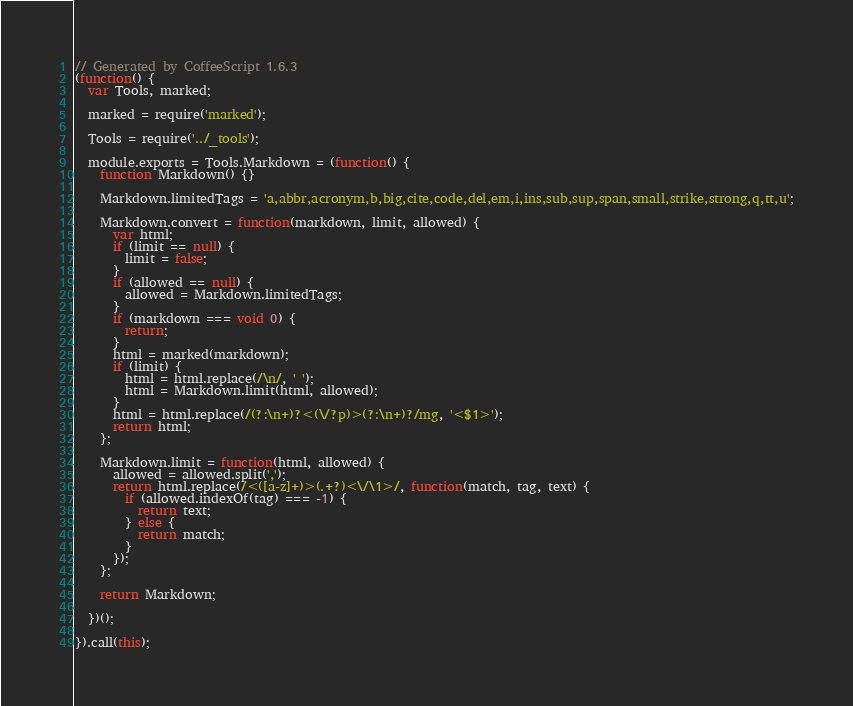<code> <loc_0><loc_0><loc_500><loc_500><_JavaScript_>// Generated by CoffeeScript 1.6.3
(function() {
  var Tools, marked;

  marked = require('marked');

  Tools = require('../_tools');

  module.exports = Tools.Markdown = (function() {
    function Markdown() {}

    Markdown.limitedTags = 'a,abbr,acronym,b,big,cite,code,del,em,i,ins,sub,sup,span,small,strike,strong,q,tt,u';

    Markdown.convert = function(markdown, limit, allowed) {
      var html;
      if (limit == null) {
        limit = false;
      }
      if (allowed == null) {
        allowed = Markdown.limitedTags;
      }
      if (markdown === void 0) {
        return;
      }
      html = marked(markdown);
      if (limit) {
        html = html.replace(/\n/, ' ');
        html = Markdown.limit(html, allowed);
      }
      html = html.replace(/(?:\n+)?<(\/?p)>(?:\n+)?/mg, '<$1>');
      return html;
    };

    Markdown.limit = function(html, allowed) {
      allowed = allowed.split(',');
      return html.replace(/<([a-z]+)>(.+?)<\/\1>/, function(match, tag, text) {
        if (allowed.indexOf(tag) === -1) {
          return text;
        } else {
          return match;
        }
      });
    };

    return Markdown;

  })();

}).call(this);
</code> 